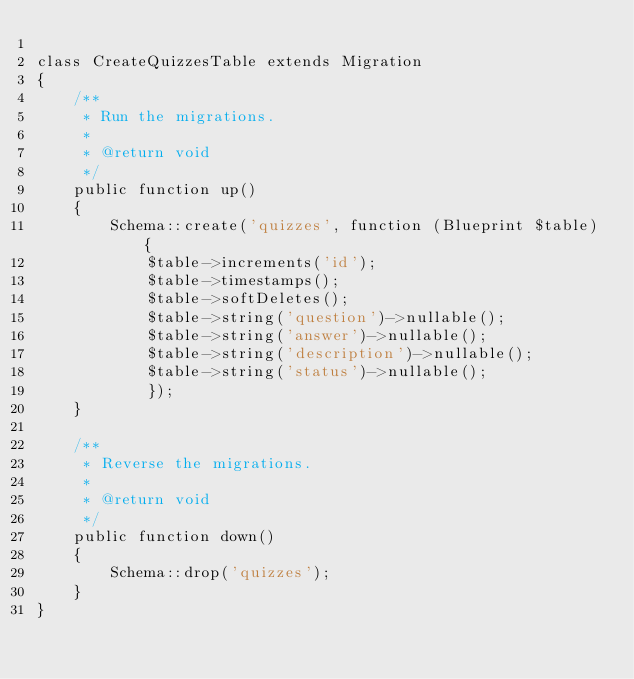Convert code to text. <code><loc_0><loc_0><loc_500><loc_500><_PHP_>
class CreateQuizzesTable extends Migration
{
    /**
     * Run the migrations.
     *
     * @return void
     */
    public function up()
    {
        Schema::create('quizzes', function (Blueprint $table) {
            $table->increments('id');
            $table->timestamps();
            $table->softDeletes();
            $table->string('question')->nullable();
            $table->string('answer')->nullable();
            $table->string('description')->nullable();
            $table->string('status')->nullable();
            });
    }

    /**
     * Reverse the migrations.
     *
     * @return void
     */
    public function down()
    {
        Schema::drop('quizzes');
    }
}
</code> 